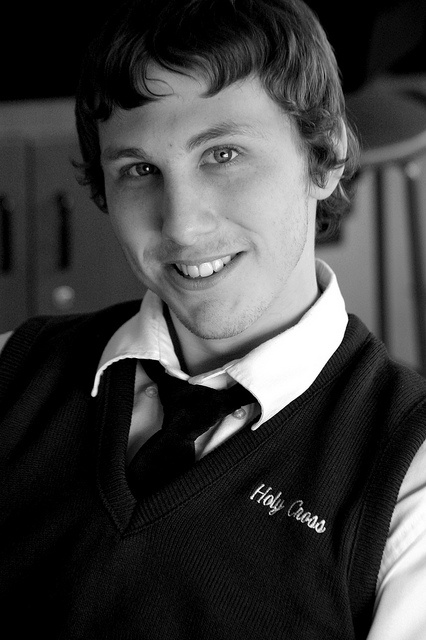Describe the objects in this image and their specific colors. I can see people in black, lightgray, darkgray, and gray tones and tie in black, gray, and lightgray tones in this image. 